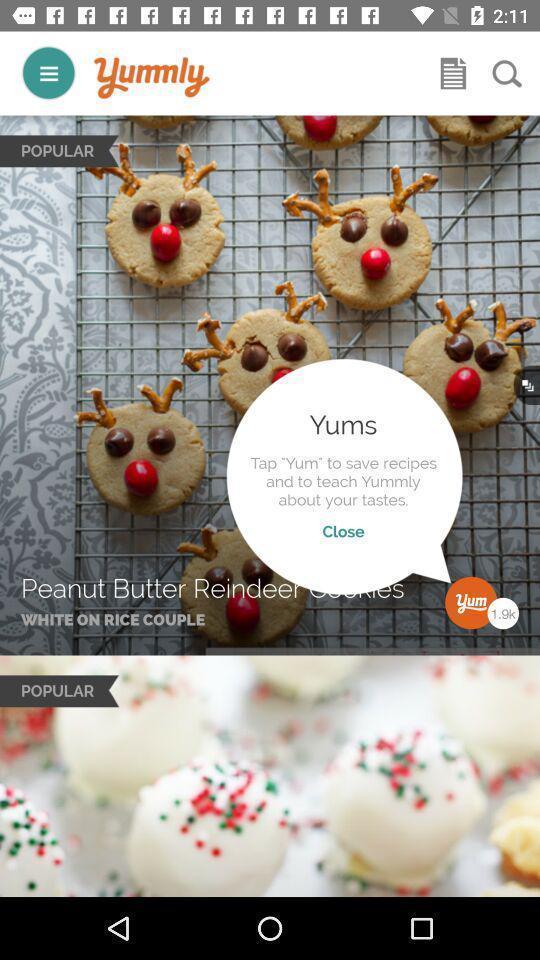What is the overall content of this screenshot? Welcome page displayed of an cooking application. 